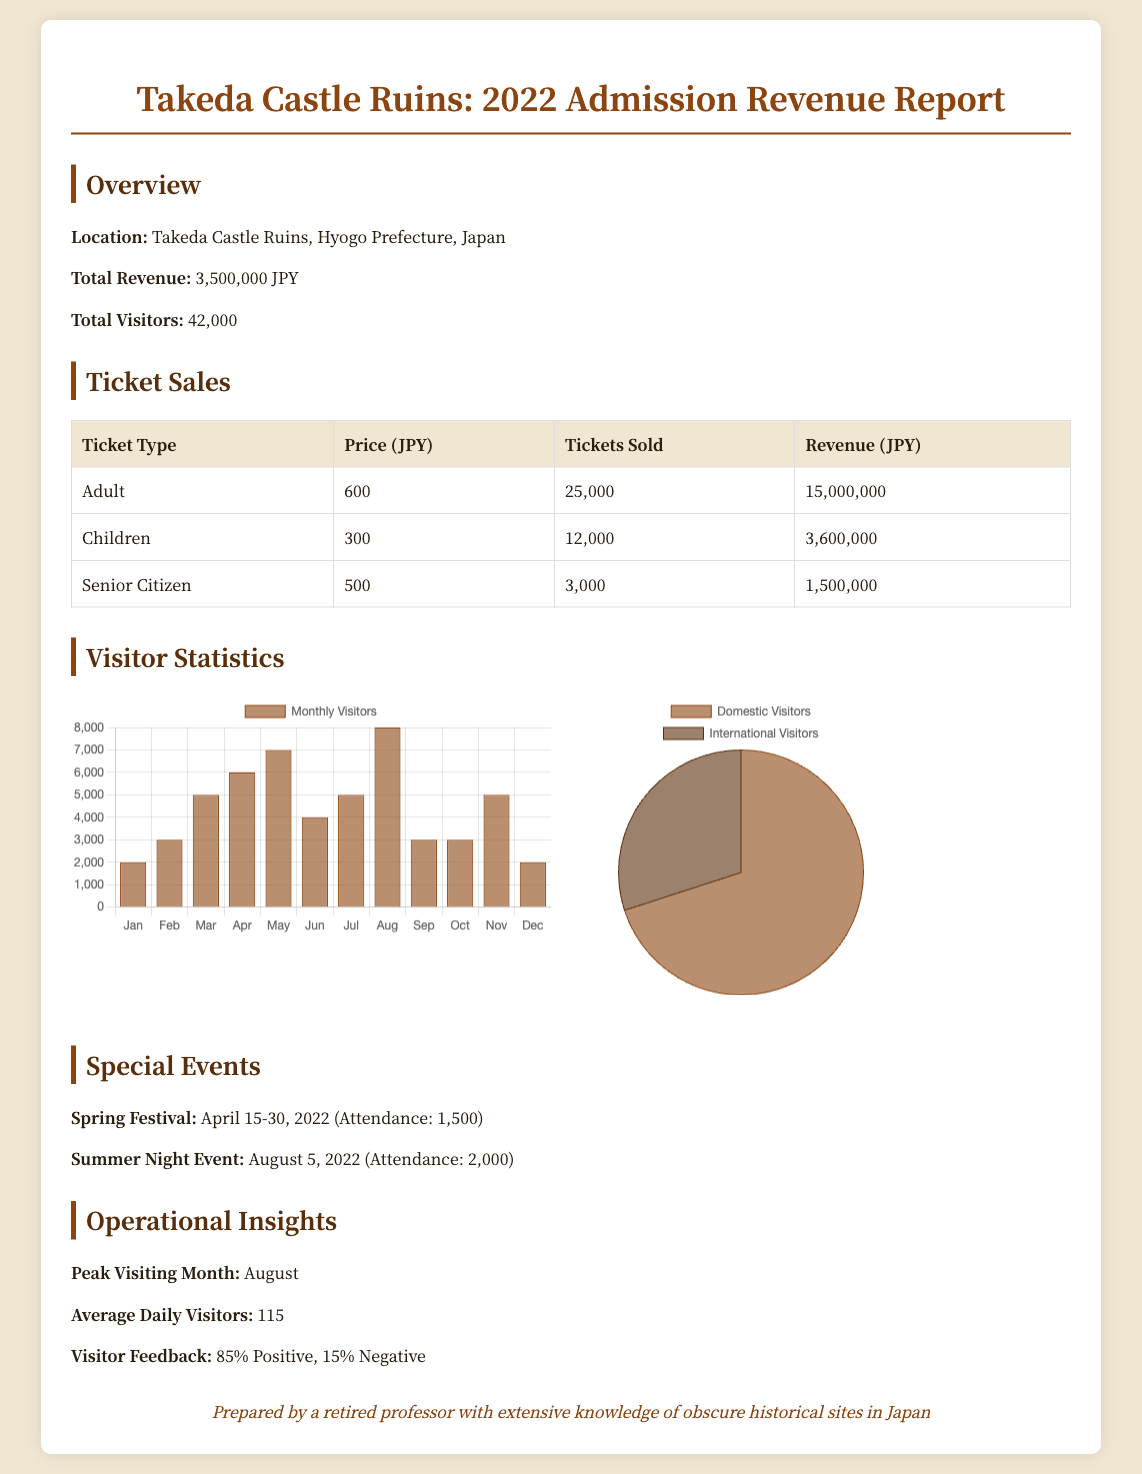What is the total revenue? The total revenue is explicitly stated in the document, totaling 3,500,000 JPY.
Answer: 3,500,000 JPY How many total visitors were recorded? The document provides the total number of visitors, which is 42,000.
Answer: 42,000 What was the ticket price for children? The document lists the ticket price for children as 300 JPY.
Answer: 300 JPY What was the peak visiting month? The peak visiting month is mentioned as August within the operational insights section.
Answer: August What percentage of visitor feedback was positive? The document states that 85% of visitor feedback was positive.
Answer: 85% How many adult tickets were sold? The number of adult tickets sold is indicated as 25,000 in the ticket sales section.
Answer: 25,000 What was the attendance for the Spring Festival? The attendance for the Spring Festival is noted as 1,500 in the special events section.
Answer: 1,500 What was the total revenue generated from children’s tickets? The revenue from children's tickets is listed as 3,600,000 JPY in the ticket sales table.
Answer: 3,600,000 JPY What is the ratio of domestic to international visitors? The visitor demographics indicate a ratio of 70% domestic to 30% international visitors.
Answer: 70% domestic, 30% international 